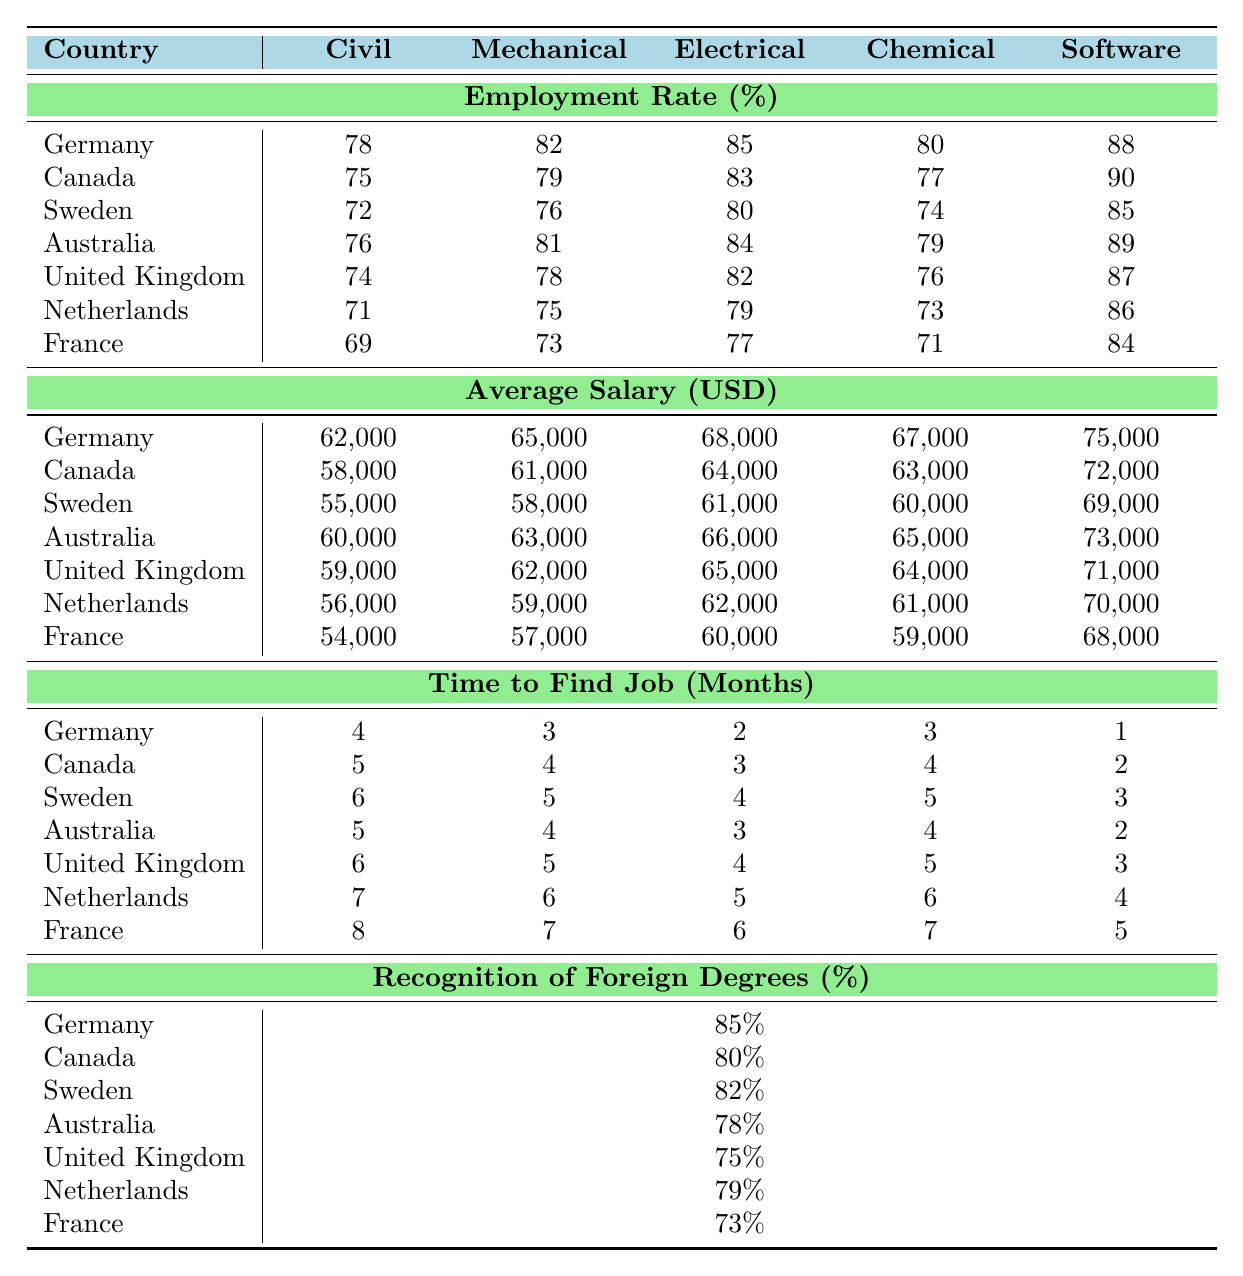What is the employment rate for Software engineers in Canada? According to the table, the employment rate for Software engineers in Canada is directly mentioned as 90%.
Answer: 90% Which country has the highest average salary for Electrical engineers? By comparing the average salaries listed for Electrical engineers in all countries, Germany has the highest average salary of $68,000.
Answer: Germany How long does it take, on average, to find a job as a Mechanical engineer in the Netherlands? The table shows that the time to find a job as a Mechanical engineer in the Netherlands is 6 months.
Answer: 6 months Is the recognition of foreign degrees higher in Germany or in Australia? The table indicates that Germany has a recognition rate of 85%, while Australia has a rate of 78%, so Germany's rate is higher.
Answer: Yes, Germany What is the average time to find a job for Chemical engineers across all countries? To find the average, we sum the times: (3 + 4 + 5 + 4 + 5 + 6 + 7) = 34 months, then divide by 7, giving an average of 34/7 ≈ 4.86 months, which rounds to about 5 months.
Answer: Approximately 5 months Which country has the lowest employment rate for Civil engineers? The employment rates for Civil engineers are listed as follows: Germany (78%), Canada (75%), Sweden (72%), Australia (76%), UK (74%), Netherlands (71%), and France (69%). The lowest rate is in France at 69%.
Answer: France Compare the average salary between Software engineers in Germany and the UK. Which one is higher? The average salary for Software engineers is $75,000 in Germany and $71,000 in the UK. Since $75,000 is greater than $71,000, Germany has the higher salary.
Answer: Germany What is the percentage of recognition of foreign degrees in Sweden? The table states that the recognition of foreign degrees in Sweden is at 82%.
Answer: 82% Calculate the difference in employment rates for Civil engineers between Germany and France. The employment rates are 78% for Germany and 69% for France. The difference is 78% - 69% = 9%.
Answer: 9% If a refugee wants to find a job as an Electrical engineer, which country offers the shortest time to find a job? Checking the time to find a job for Electrical engineers: Germany (2), Canada (3), Sweden (4), Australia (3), UK (4), Netherlands (5), and France (6). Germany has the shortest time of 2 months.
Answer: Germany 